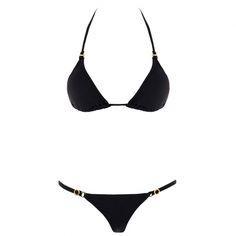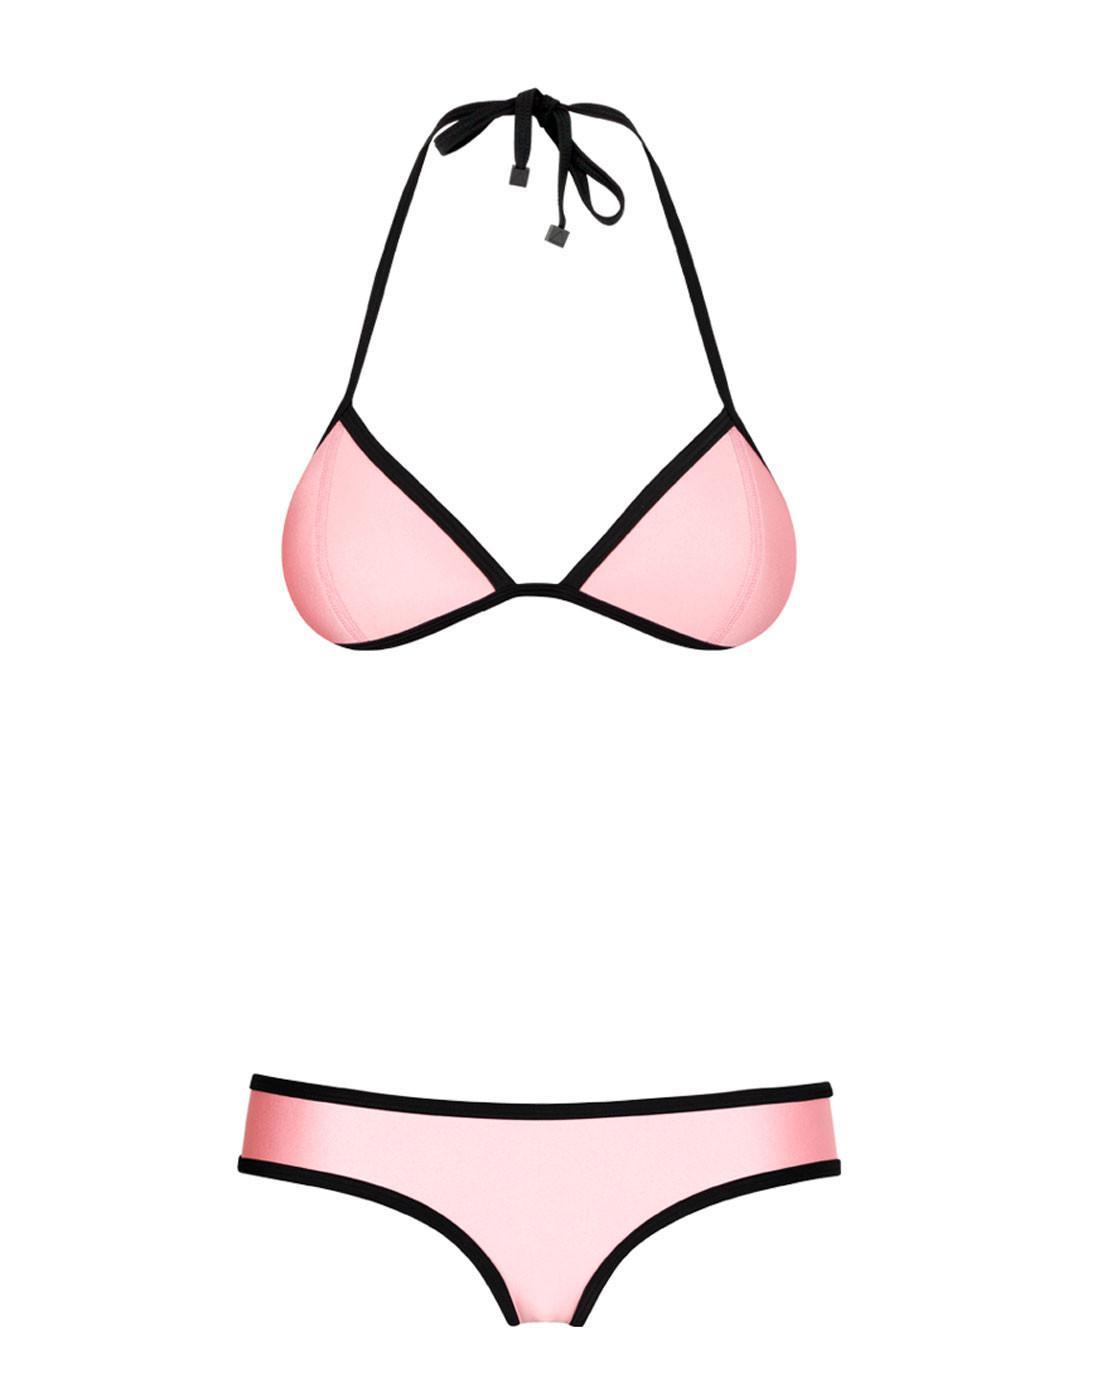The first image is the image on the left, the second image is the image on the right. For the images shown, is this caption "Both swimsuits are primarily black in color" true? Answer yes or no. No. 